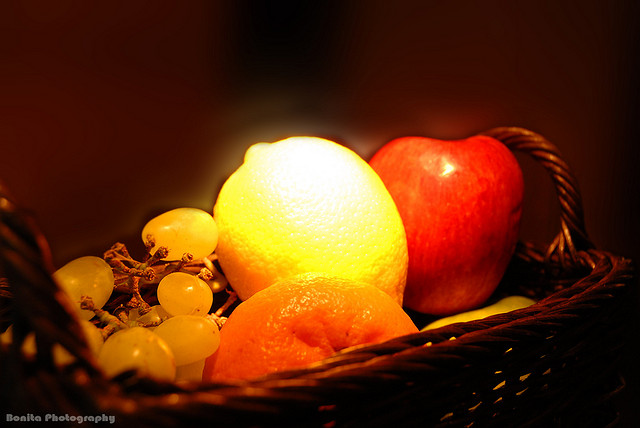Identify the text displayed in this image. Bonita Photography 